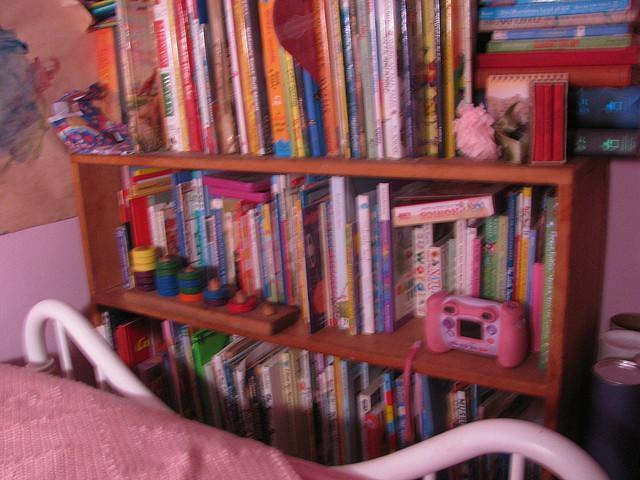How many books are there?
Give a very brief answer. 9. How many people are wearing an orange shirt in this image?
Give a very brief answer. 0. 